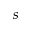Convert formula to latex. <formula><loc_0><loc_0><loc_500><loc_500>s</formula> 